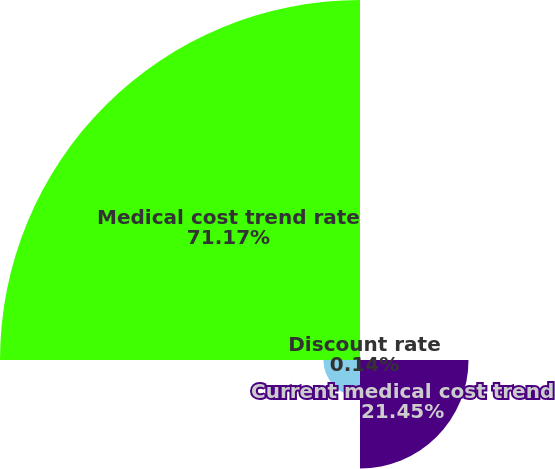<chart> <loc_0><loc_0><loc_500><loc_500><pie_chart><fcel>Discount rate<fcel>Current medical cost trend<fcel>Ultimate medical cost trend<fcel>Medical cost trend rate<nl><fcel>0.14%<fcel>21.45%<fcel>7.24%<fcel>71.17%<nl></chart> 